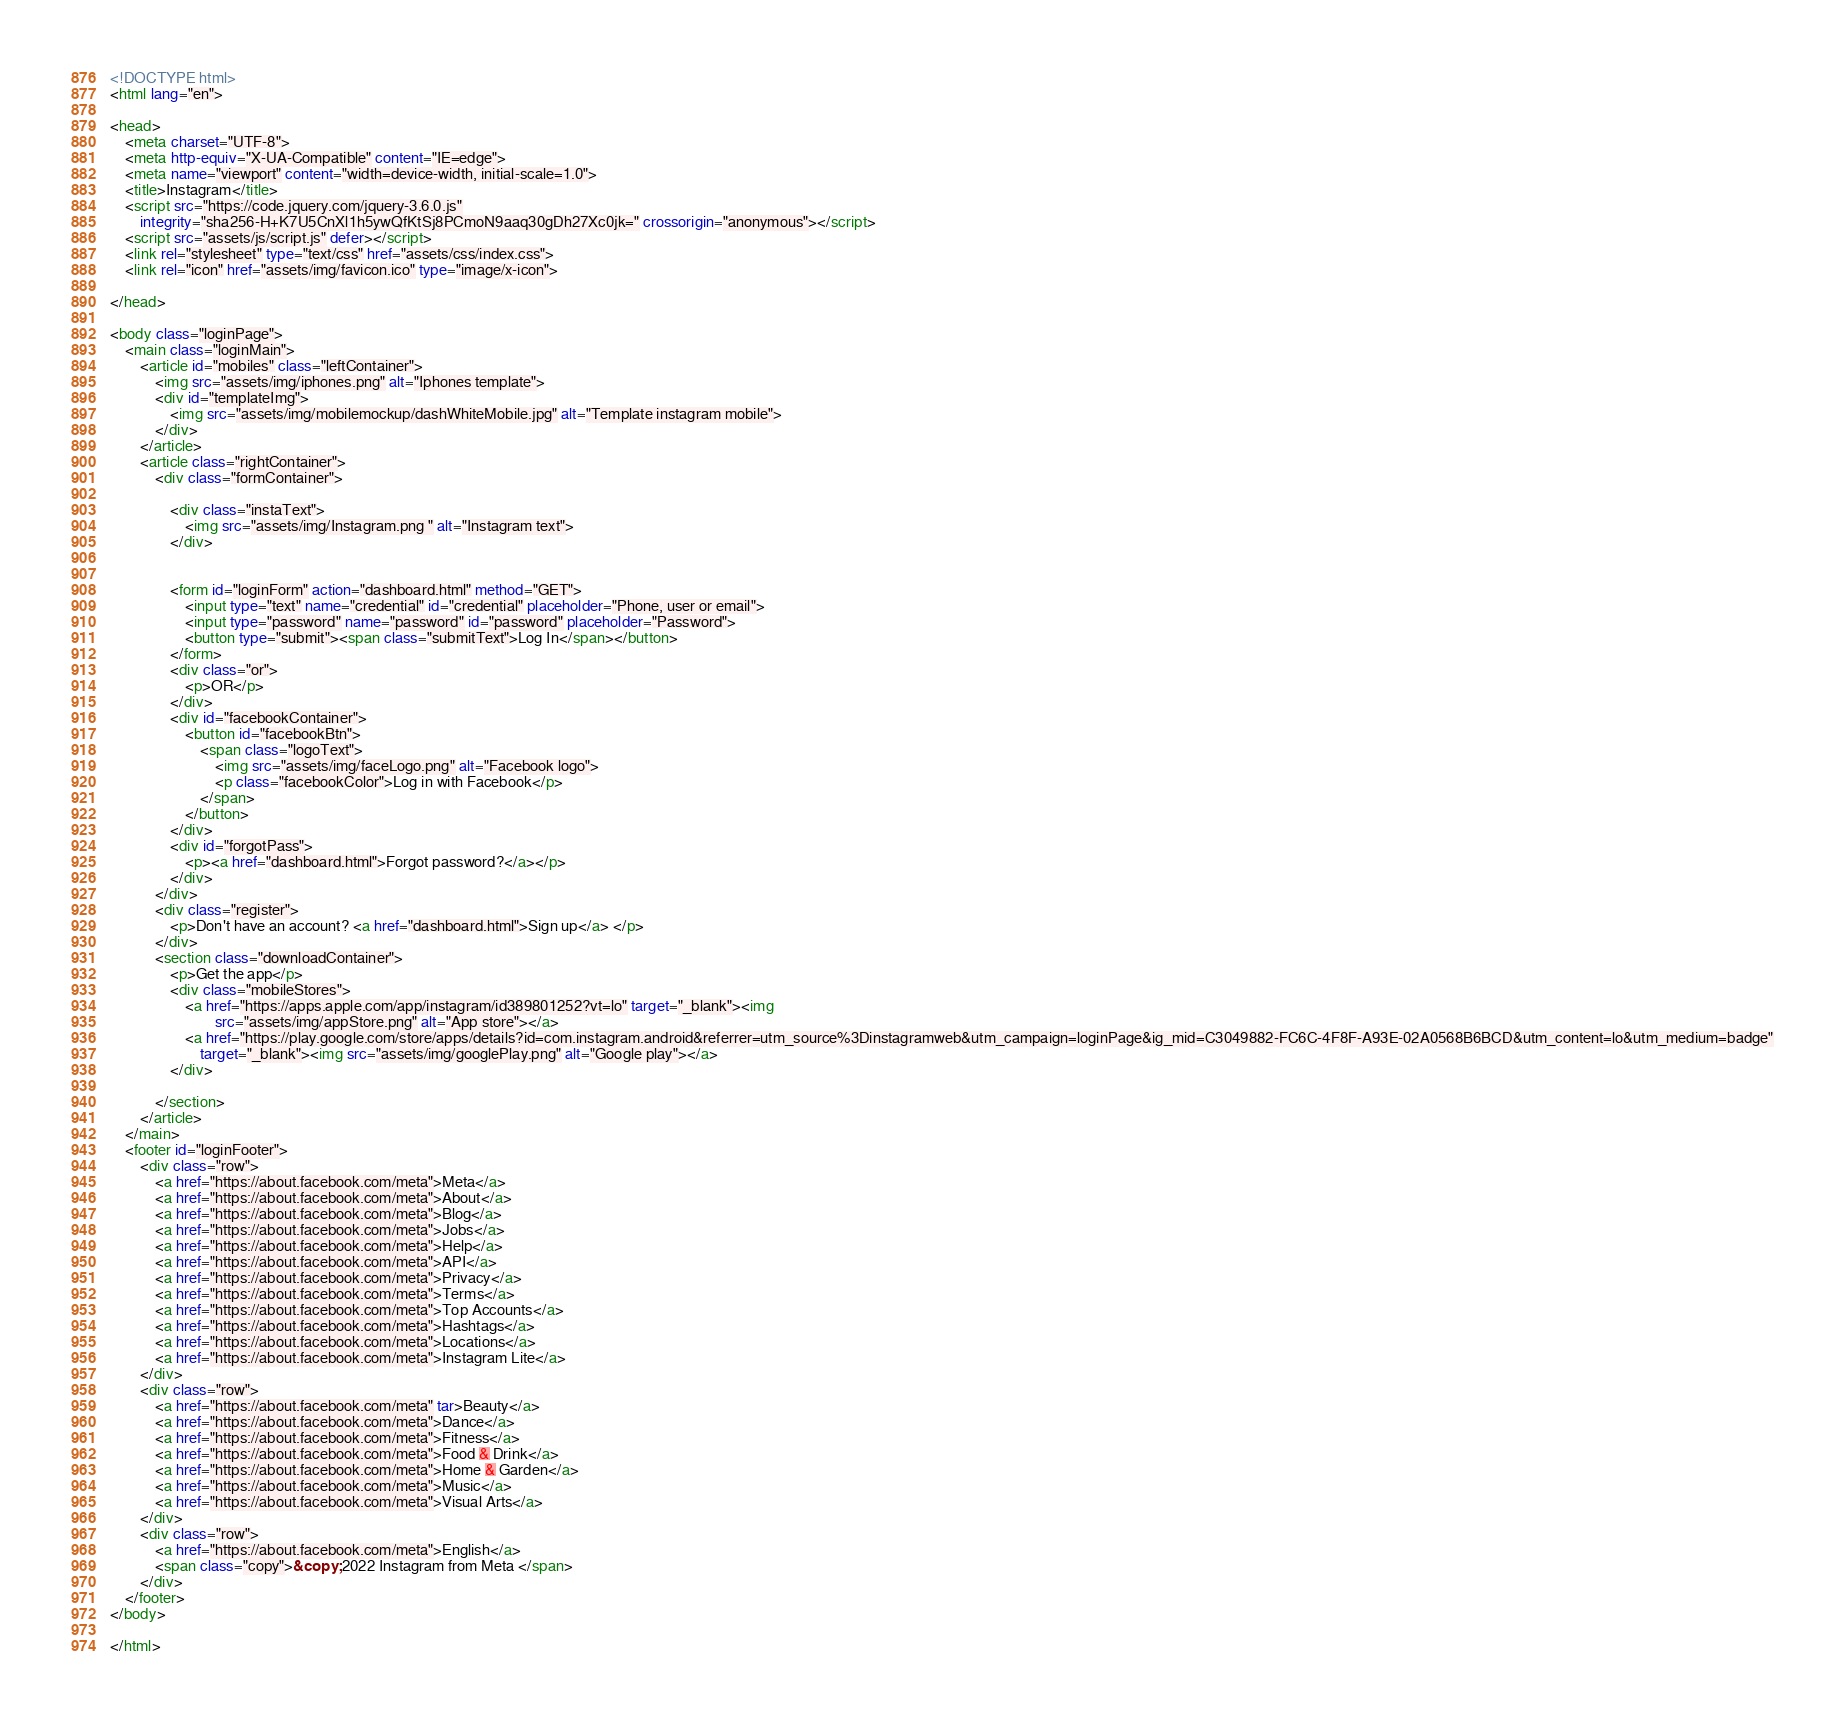Convert code to text. <code><loc_0><loc_0><loc_500><loc_500><_HTML_><!DOCTYPE html>
<html lang="en">

<head>
    <meta charset="UTF-8">
    <meta http-equiv="X-UA-Compatible" content="IE=edge">
    <meta name="viewport" content="width=device-width, initial-scale=1.0">
    <title>Instagram</title>
    <script src="https://code.jquery.com/jquery-3.6.0.js"
        integrity="sha256-H+K7U5CnXl1h5ywQfKtSj8PCmoN9aaq30gDh27Xc0jk=" crossorigin="anonymous"></script>
    <script src="assets/js/script.js" defer></script>
    <link rel="stylesheet" type="text/css" href="assets/css/index.css">
    <link rel="icon" href="assets/img/favicon.ico" type="image/x-icon">

</head>

<body class="loginPage">
    <main class="loginMain">
        <article id="mobiles" class="leftContainer">
            <img src="assets/img/iphones.png" alt="Iphones template">
            <div id="templateImg">
                <img src="assets/img/mobilemockup/dashWhiteMobile.jpg" alt="Template instagram mobile">
            </div>
        </article>
        <article class="rightContainer">
            <div class="formContainer">

                <div class="instaText">
                    <img src="assets/img/Instagram.png " alt="Instagram text">
                </div>


                <form id="loginForm" action="dashboard.html" method="GET">
                    <input type="text" name="credential" id="credential" placeholder="Phone, user or email">
                    <input type="password" name="password" id="password" placeholder="Password">
                    <button type="submit"><span class="submitText">Log In</span></button>
                </form>
                <div class="or">
                    <p>OR</p>
                </div>
                <div id="facebookContainer">
                    <button id="facebookBtn">
                        <span class="logoText">
                            <img src="assets/img/faceLogo.png" alt="Facebook logo">
                            <p class="facebookColor">Log in with Facebook</p>
                        </span>
                    </button>
                </div>
                <div id="forgotPass">
                    <p><a href="dashboard.html">Forgot password?</a></p>
                </div>
            </div>
            <div class="register">
                <p>Don't have an account? <a href="dashboard.html">Sign up</a> </p>
            </div>
            <section class="downloadContainer">
                <p>Get the app</p>
                <div class="mobileStores">
                    <a href="https://apps.apple.com/app/instagram/id389801252?vt=lo" target="_blank"><img
                            src="assets/img/appStore.png" alt="App store"></a>
                    <a href="https://play.google.com/store/apps/details?id=com.instagram.android&referrer=utm_source%3Dinstagramweb&utm_campaign=loginPage&ig_mid=C3049882-FC6C-4F8F-A93E-02A0568B6BCD&utm_content=lo&utm_medium=badge"
                        target="_blank"><img src="assets/img/googlePlay.png" alt="Google play"></a>
                </div>

            </section>
        </article>
    </main>
    <footer id="loginFooter">
        <div class="row">
            <a href="https://about.facebook.com/meta">Meta</a>
            <a href="https://about.facebook.com/meta">About</a>
            <a href="https://about.facebook.com/meta">Blog</a>
            <a href="https://about.facebook.com/meta">Jobs</a>
            <a href="https://about.facebook.com/meta">Help</a>
            <a href="https://about.facebook.com/meta">API</a>
            <a href="https://about.facebook.com/meta">Privacy</a>
            <a href="https://about.facebook.com/meta">Terms</a>
            <a href="https://about.facebook.com/meta">Top Accounts</a>
            <a href="https://about.facebook.com/meta">Hashtags</a>
            <a href="https://about.facebook.com/meta">Locations</a>
            <a href="https://about.facebook.com/meta">Instagram Lite</a>
        </div>
        <div class="row">
            <a href="https://about.facebook.com/meta" tar>Beauty</a>
            <a href="https://about.facebook.com/meta">Dance</a>
            <a href="https://about.facebook.com/meta">Fitness</a>
            <a href="https://about.facebook.com/meta">Food & Drink</a>
            <a href="https://about.facebook.com/meta">Home & Garden</a>
            <a href="https://about.facebook.com/meta">Music</a>
            <a href="https://about.facebook.com/meta">Visual Arts</a>
        </div>
        <div class="row">
            <a href="https://about.facebook.com/meta">English</a>
            <span class="copy">&copy; 2022 Instagram from Meta </span>
        </div>
    </footer>
</body>

</html></code> 